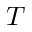<formula> <loc_0><loc_0><loc_500><loc_500>T</formula> 